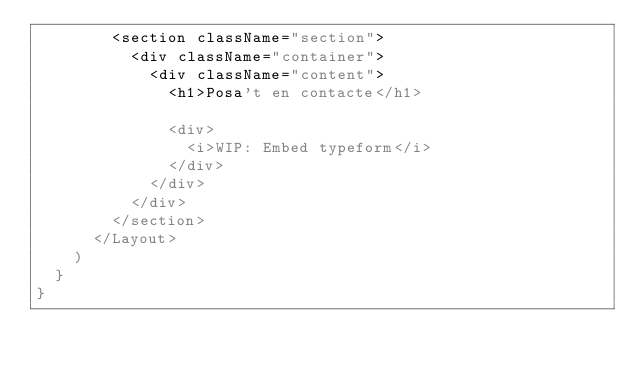<code> <loc_0><loc_0><loc_500><loc_500><_JavaScript_>        <section className="section">
          <div className="container">
            <div className="content">
              <h1>Posa't en contacte</h1>

              <div>
                <i>WIP: Embed typeform</i>
              </div>
            </div>
          </div>
        </section>
      </Layout>
    )
  }
}
</code> 